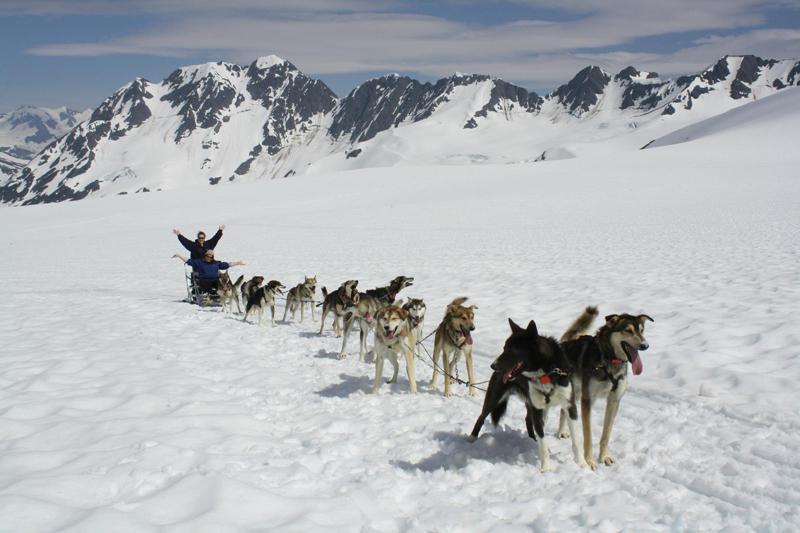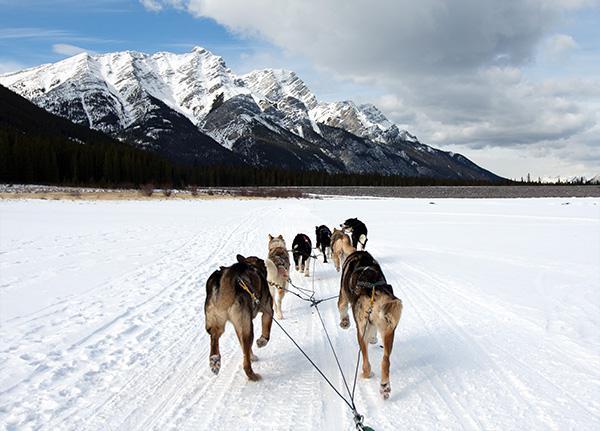The first image is the image on the left, the second image is the image on the right. Examine the images to the left and right. Is the description "Both riders are wearing red jackets." accurate? Answer yes or no. No. The first image is the image on the left, the second image is the image on the right. For the images displayed, is the sentence "The sled dog teams in the two images are heading in the same direction on a non-curved path." factually correct? Answer yes or no. No. 